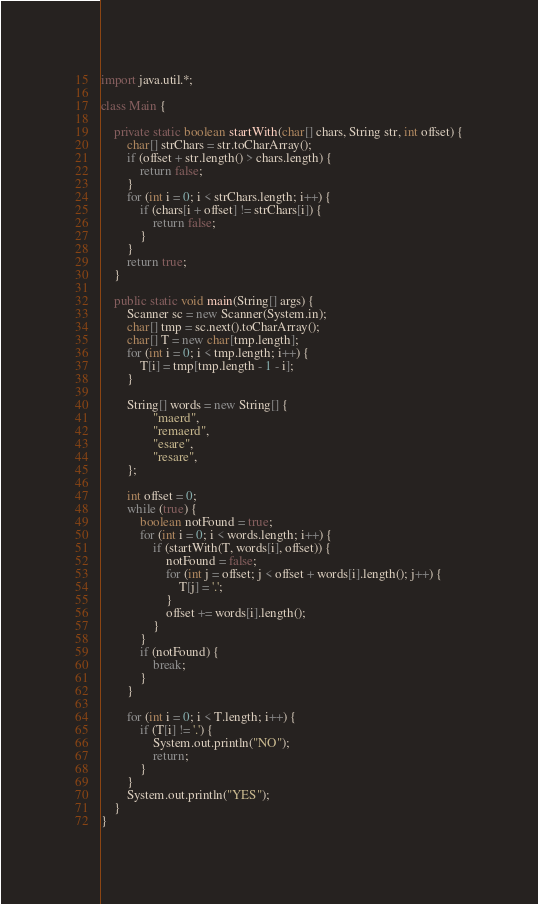<code> <loc_0><loc_0><loc_500><loc_500><_Java_>import java.util.*;

class Main {

    private static boolean startWith(char[] chars, String str, int offset) {
        char[] strChars = str.toCharArray();
        if (offset + str.length() > chars.length) {
            return false;
        }
        for (int i = 0; i < strChars.length; i++) {
            if (chars[i + offset] != strChars[i]) {
                return false;
            }
        }
        return true;
    }

    public static void main(String[] args) {
        Scanner sc = new Scanner(System.in);
        char[] tmp = sc.next().toCharArray();
        char[] T = new char[tmp.length];
        for (int i = 0; i < tmp.length; i++) {
            T[i] = tmp[tmp.length - 1 - i];
        }

        String[] words = new String[] {
                "maerd",
                "remaerd",
                "esare",
                "resare",
        };

        int offset = 0;
        while (true) {
            boolean notFound = true;
            for (int i = 0; i < words.length; i++) {
                if (startWith(T, words[i], offset)) {
                    notFound = false;
                    for (int j = offset; j < offset + words[i].length(); j++) {
                        T[j] = '.';
                    }
                    offset += words[i].length();
                }
            }
            if (notFound) {
                break;
            }
        }

        for (int i = 0; i < T.length; i++) {
            if (T[i] != '.') {
                System.out.println("NO");
                return;
            }
        }
        System.out.println("YES");
    }
}</code> 